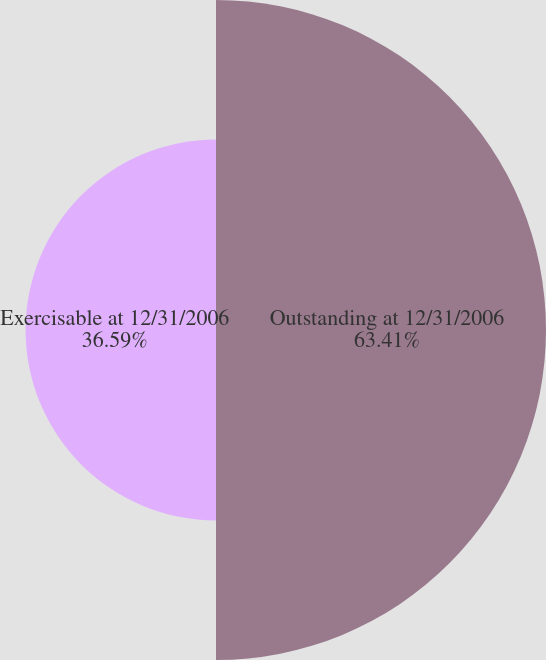Convert chart to OTSL. <chart><loc_0><loc_0><loc_500><loc_500><pie_chart><fcel>Outstanding at 12/31/2006<fcel>Exercisable at 12/31/2006<nl><fcel>63.41%<fcel>36.59%<nl></chart> 